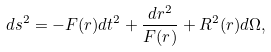<formula> <loc_0><loc_0><loc_500><loc_500>d s ^ { 2 } = - F ( r ) d t ^ { 2 } + { \frac { d r ^ { 2 } } { F ( r ) } } + R ^ { 2 } ( r ) d \Omega ,</formula> 